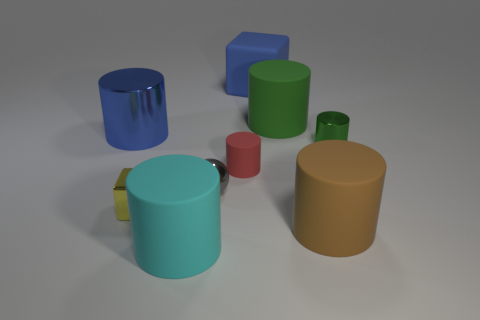Subtract all large green cylinders. How many cylinders are left? 5 Add 1 tiny brown metal cylinders. How many objects exist? 10 Subtract 1 cylinders. How many cylinders are left? 5 Subtract all gray spheres. How many red cylinders are left? 1 Subtract all large matte cubes. Subtract all rubber cylinders. How many objects are left? 4 Add 7 big cyan matte cylinders. How many big cyan matte cylinders are left? 8 Add 9 small brown matte balls. How many small brown matte balls exist? 9 Subtract all blue blocks. How many blocks are left? 1 Subtract 0 yellow cylinders. How many objects are left? 9 Subtract all spheres. How many objects are left? 8 